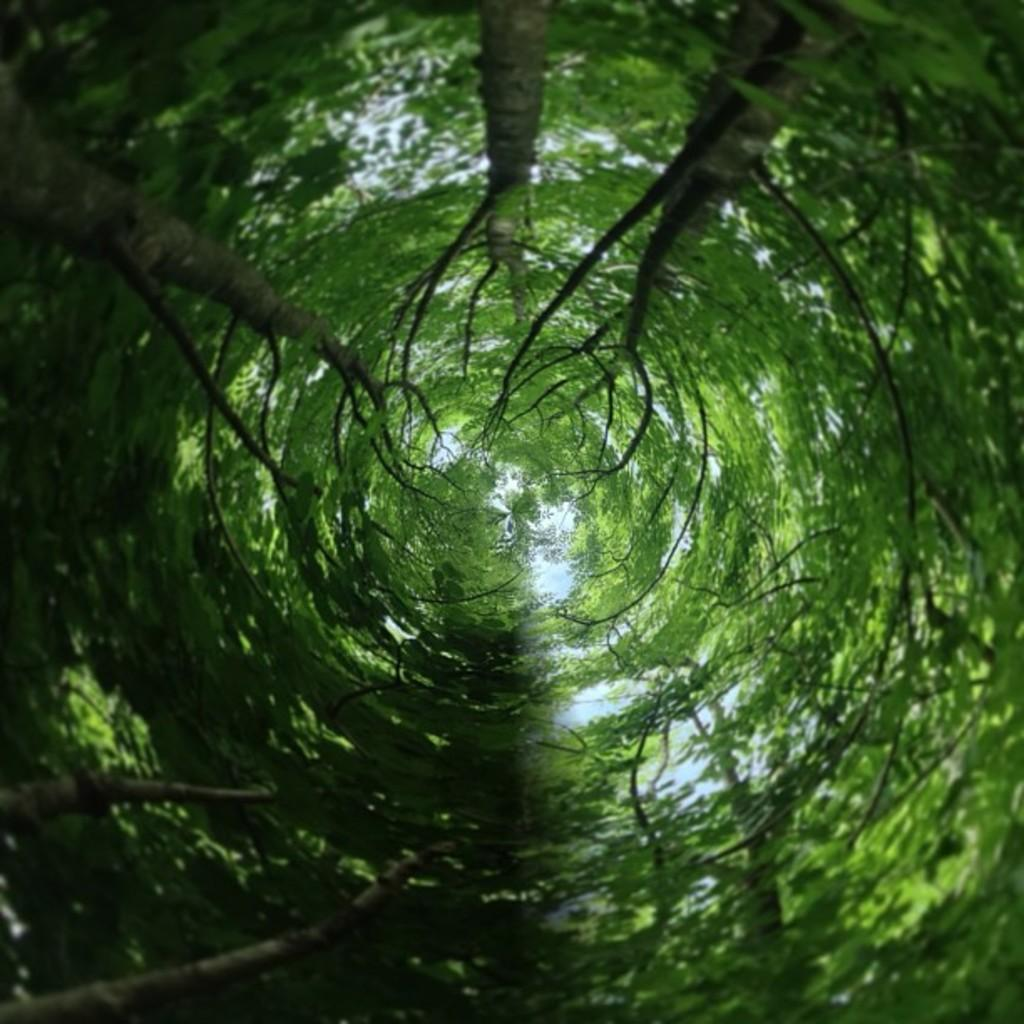What type of vegetation can be seen in the image? There are trees in the image. What part of the natural environment is visible in the image? The sky is visible in the image. How many bikes are parked in the room in the image? There are no bikes or rooms present in the image; it features trees and the sky. What type of work is being done in the image? There is no work being done in the image; it only shows trees and the sky. 